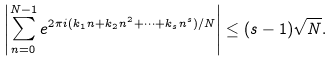Convert formula to latex. <formula><loc_0><loc_0><loc_500><loc_500>\left | \sum _ { n = 0 } ^ { N - 1 } e ^ { 2 \pi i ( k _ { 1 } n + k _ { 2 } n ^ { 2 } + \cdots + k _ { s } n ^ { s } ) / N } \right | \leq ( s - 1 ) \sqrt { N } .</formula> 